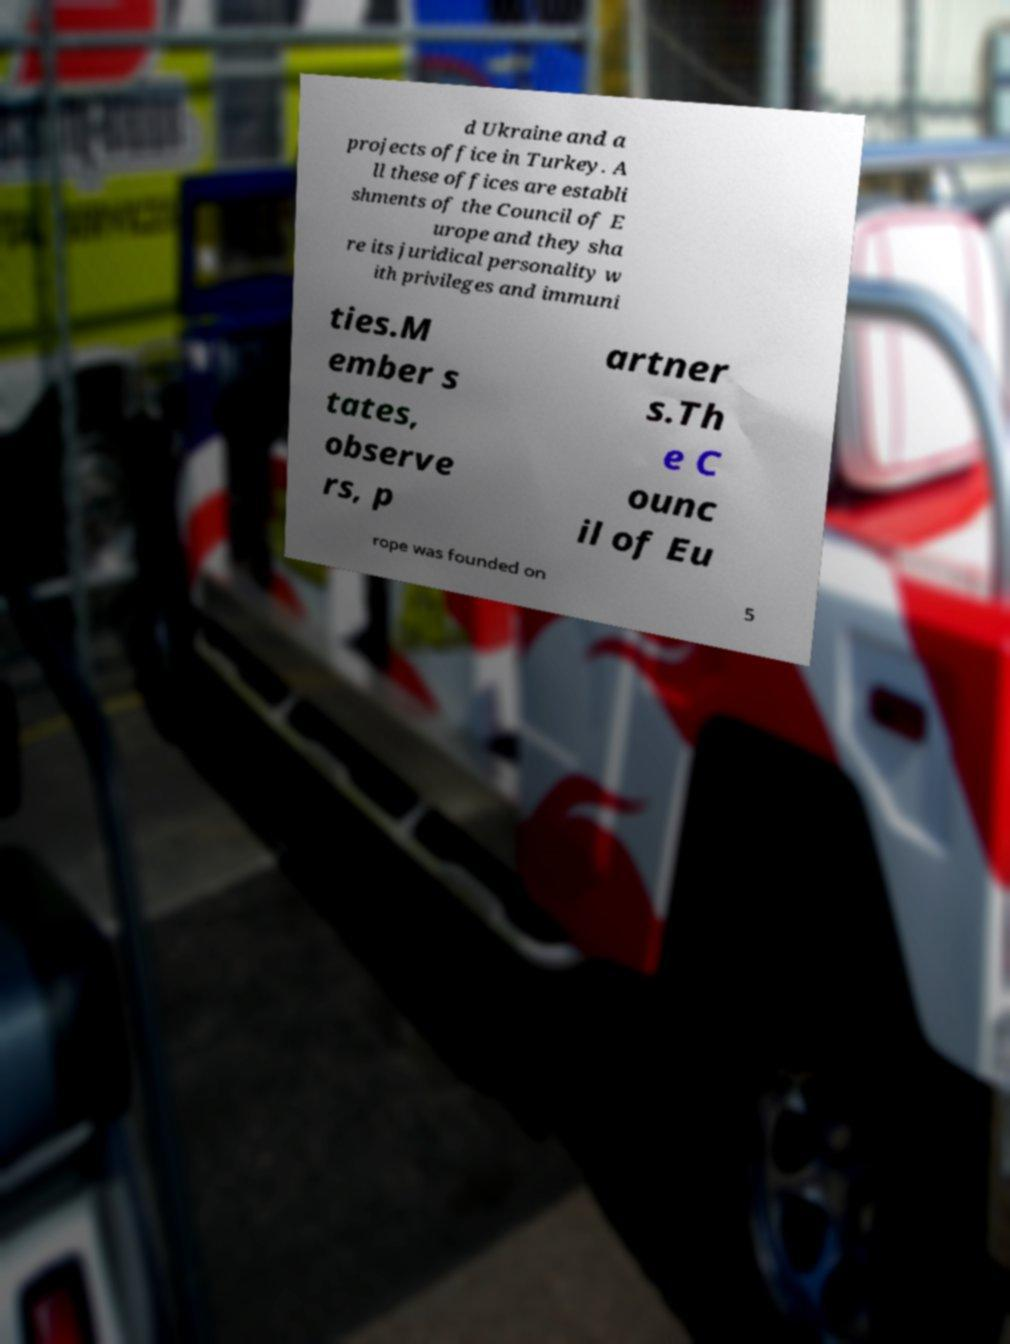Please identify and transcribe the text found in this image. d Ukraine and a projects office in Turkey. A ll these offices are establi shments of the Council of E urope and they sha re its juridical personality w ith privileges and immuni ties.M ember s tates, observe rs, p artner s.Th e C ounc il of Eu rope was founded on 5 